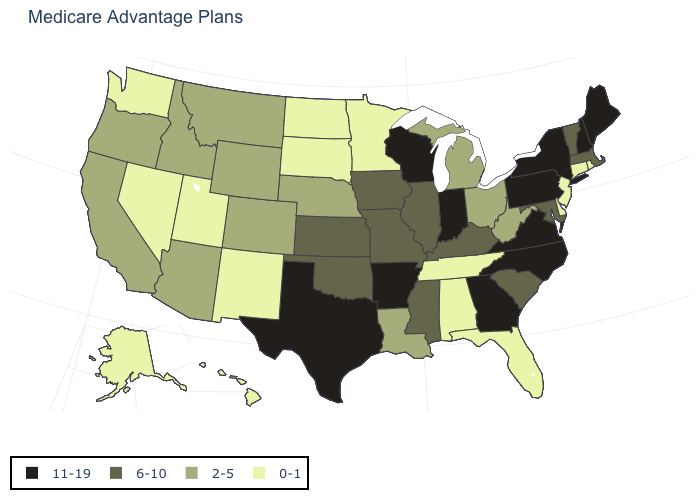Does Connecticut have the lowest value in the USA?
Keep it brief. Yes. Is the legend a continuous bar?
Concise answer only. No. What is the value of Pennsylvania?
Write a very short answer. 11-19. Name the states that have a value in the range 11-19?
Write a very short answer. Arkansas, Georgia, Indiana, Maine, North Carolina, New Hampshire, New York, Pennsylvania, Texas, Virginia, Wisconsin. Does Utah have the lowest value in the USA?
Keep it brief. Yes. Name the states that have a value in the range 11-19?
Be succinct. Arkansas, Georgia, Indiana, Maine, North Carolina, New Hampshire, New York, Pennsylvania, Texas, Virginia, Wisconsin. Does North Dakota have the lowest value in the MidWest?
Be succinct. Yes. What is the lowest value in the USA?
Answer briefly. 0-1. What is the highest value in the West ?
Write a very short answer. 2-5. Is the legend a continuous bar?
Answer briefly. No. Among the states that border Michigan , which have the highest value?
Concise answer only. Indiana, Wisconsin. Does Rhode Island have the highest value in the Northeast?
Short answer required. No. Among the states that border Vermont , which have the highest value?
Give a very brief answer. New Hampshire, New York. Does the map have missing data?
Quick response, please. No. Does the map have missing data?
Keep it brief. No. 